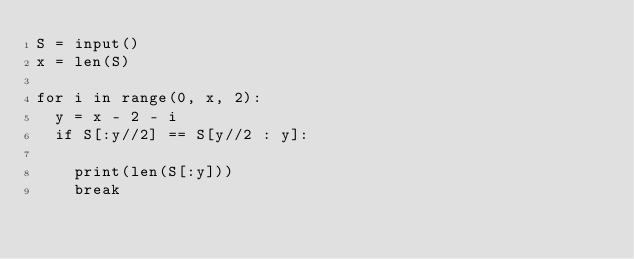Convert code to text. <code><loc_0><loc_0><loc_500><loc_500><_Python_>S = input()
x = len(S)

for i in range(0, x, 2):
  y = x - 2 - i
  if S[:y//2] == S[y//2 : y]:
    
    print(len(S[:y]))
    break</code> 